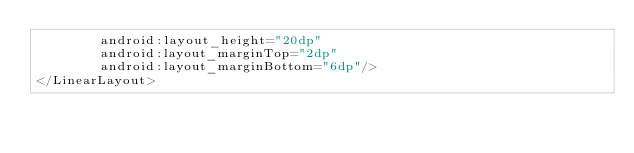<code> <loc_0><loc_0><loc_500><loc_500><_XML_>        android:layout_height="20dp"
        android:layout_marginTop="2dp"
        android:layout_marginBottom="6dp"/>
</LinearLayout></code> 